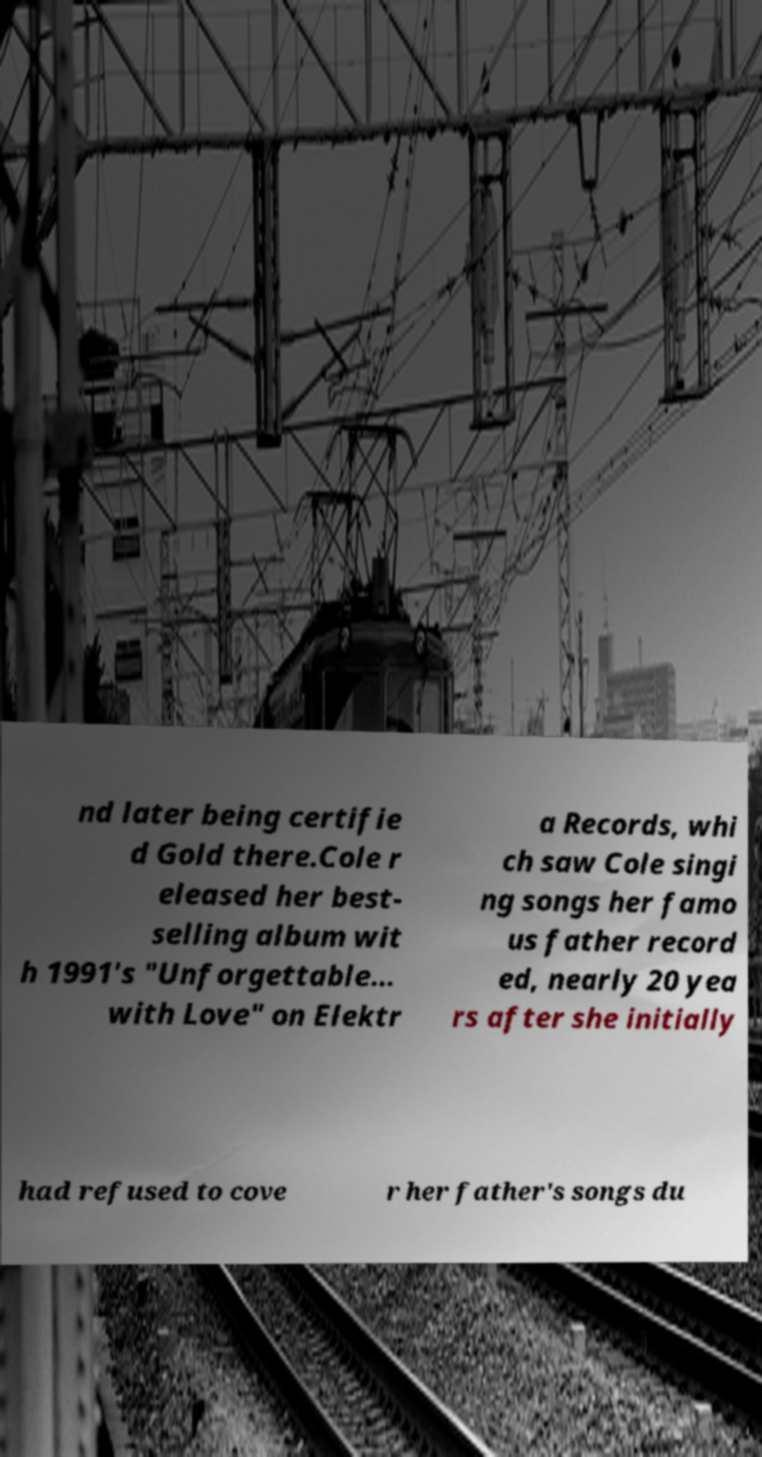For documentation purposes, I need the text within this image transcribed. Could you provide that? nd later being certifie d Gold there.Cole r eleased her best- selling album wit h 1991's "Unforgettable... with Love" on Elektr a Records, whi ch saw Cole singi ng songs her famo us father record ed, nearly 20 yea rs after she initially had refused to cove r her father's songs du 